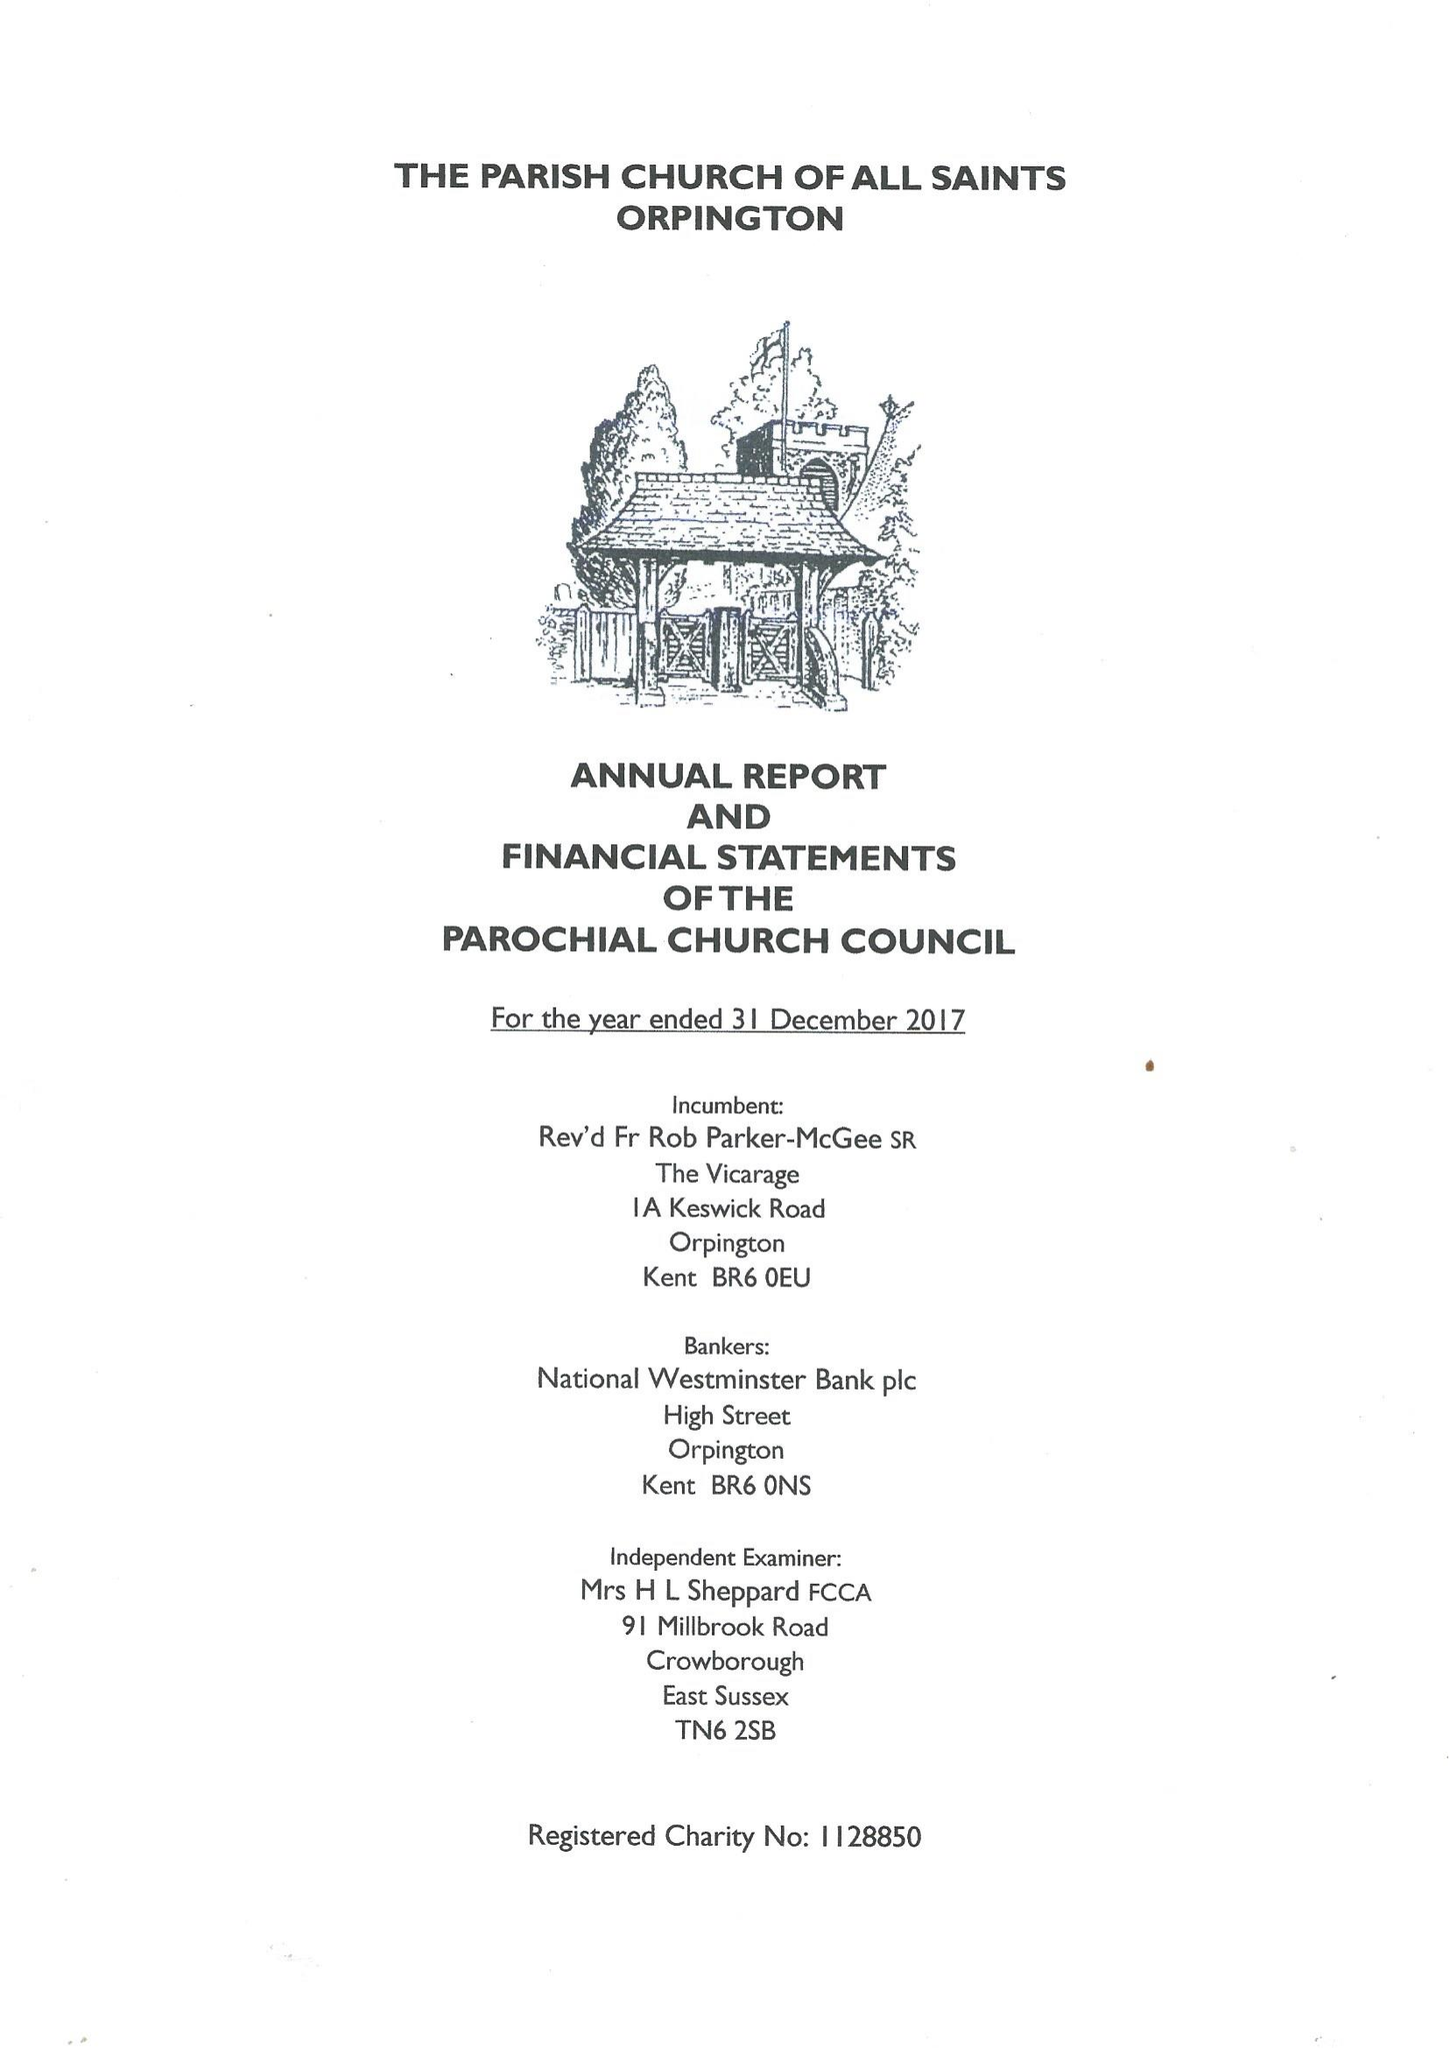What is the value for the address__street_line?
Answer the question using a single word or phrase. 44 BARK HART ROAD 